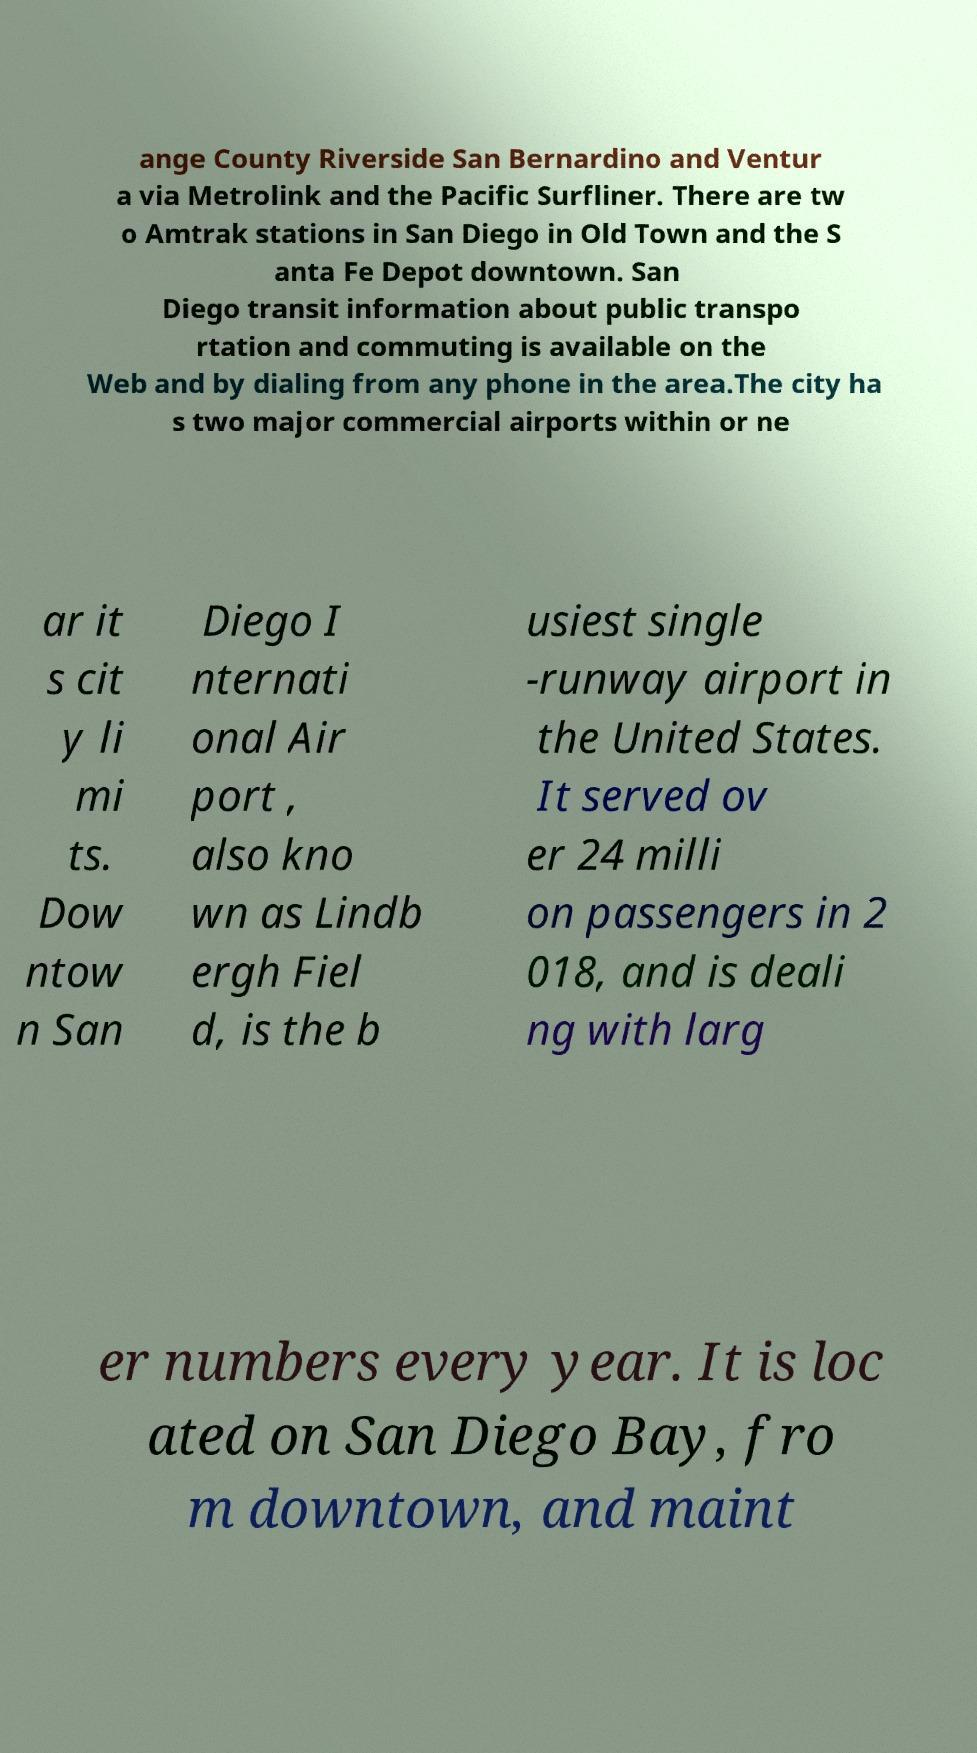Can you accurately transcribe the text from the provided image for me? ange County Riverside San Bernardino and Ventur a via Metrolink and the Pacific Surfliner. There are tw o Amtrak stations in San Diego in Old Town and the S anta Fe Depot downtown. San Diego transit information about public transpo rtation and commuting is available on the Web and by dialing from any phone in the area.The city ha s two major commercial airports within or ne ar it s cit y li mi ts. Dow ntow n San Diego I nternati onal Air port , also kno wn as Lindb ergh Fiel d, is the b usiest single -runway airport in the United States. It served ov er 24 milli on passengers in 2 018, and is deali ng with larg er numbers every year. It is loc ated on San Diego Bay, fro m downtown, and maint 